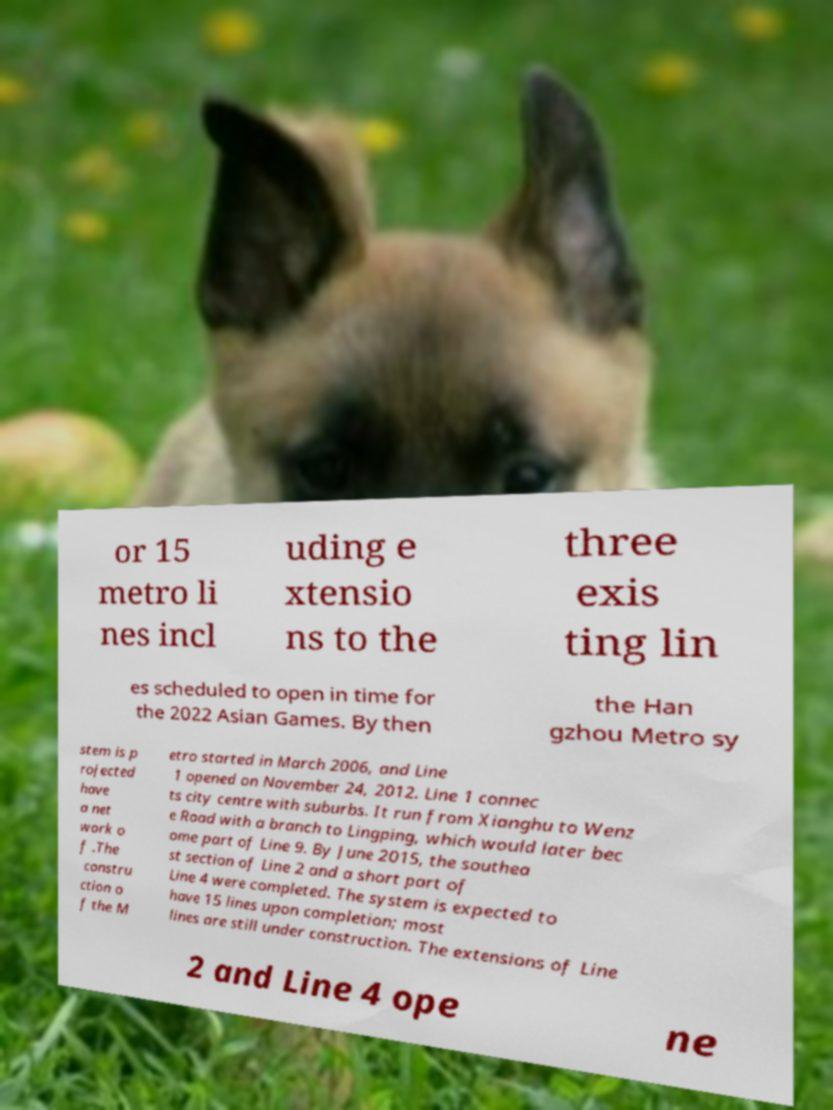Please read and relay the text visible in this image. What does it say? or 15 metro li nes incl uding e xtensio ns to the three exis ting lin es scheduled to open in time for the 2022 Asian Games. By then the Han gzhou Metro sy stem is p rojected have a net work o f .The constru ction o f the M etro started in March 2006, and Line 1 opened on November 24, 2012. Line 1 connec ts city centre with suburbs. It run from Xianghu to Wenz e Road with a branch to Lingping, which would later bec ome part of Line 9. By June 2015, the southea st section of Line 2 and a short part of Line 4 were completed. The system is expected to have 15 lines upon completion; most lines are still under construction. The extensions of Line 2 and Line 4 ope ne 